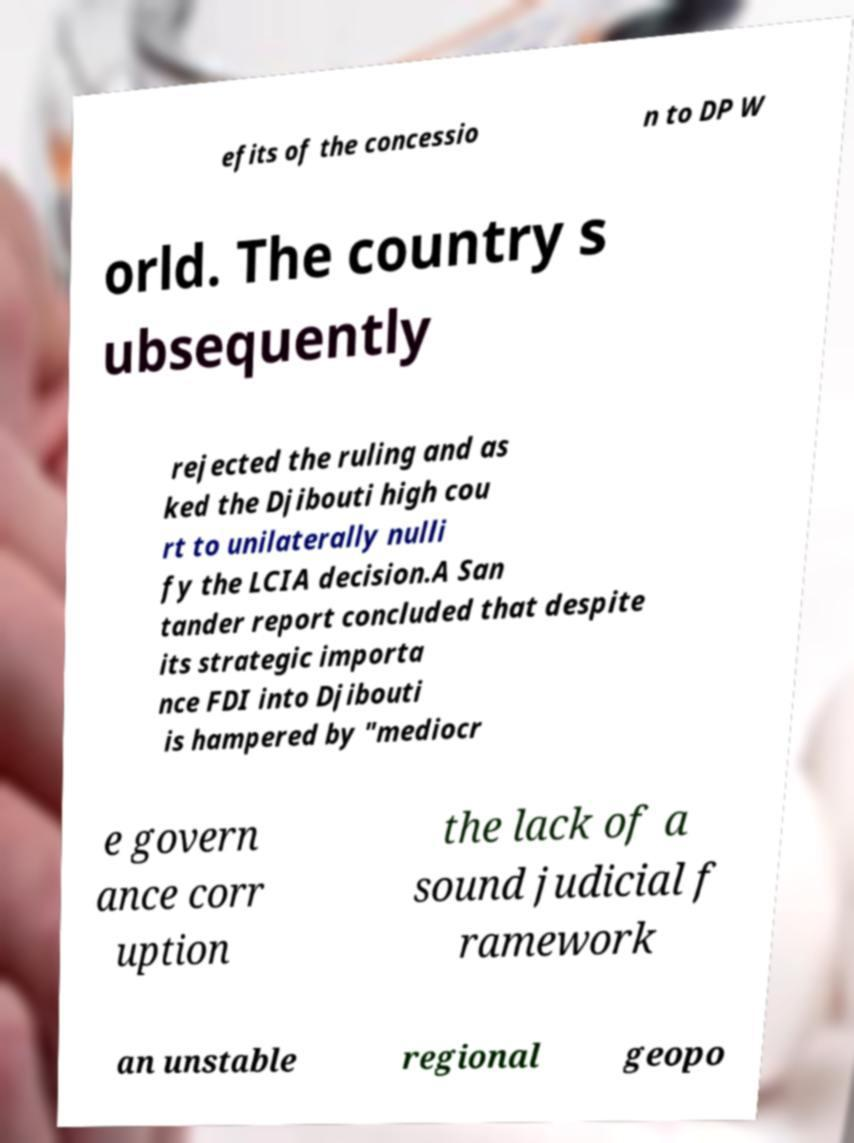Please read and relay the text visible in this image. What does it say? efits of the concessio n to DP W orld. The country s ubsequently rejected the ruling and as ked the Djibouti high cou rt to unilaterally nulli fy the LCIA decision.A San tander report concluded that despite its strategic importa nce FDI into Djibouti is hampered by "mediocr e govern ance corr uption the lack of a sound judicial f ramework an unstable regional geopo 